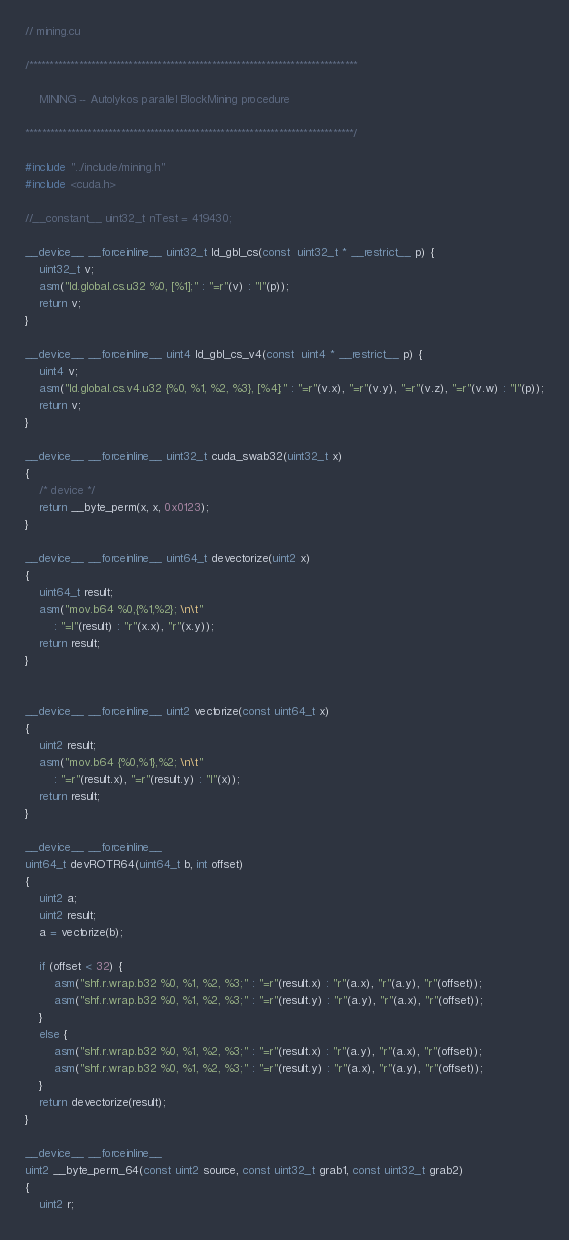<code> <loc_0><loc_0><loc_500><loc_500><_Cuda_>// mining.cu

/*******************************************************************************

    MINING -- Autolykos parallel BlockMining procedure

*******************************************************************************/

#include "../include/mining.h"
#include <cuda.h>

//__constant__ uint32_t nTest = 419430;

__device__ __forceinline__ uint32_t ld_gbl_cs(const  uint32_t * __restrict__ p) {
	uint32_t v;
	asm("ld.global.cs.u32 %0, [%1];" : "=r"(v) : "l"(p));
	return v;
}

__device__ __forceinline__ uint4 ld_gbl_cs_v4(const  uint4 * __restrict__ p) {
	uint4 v;
	asm("ld.global.cs.v4.u32 {%0, %1, %2, %3}, [%4];" : "=r"(v.x), "=r"(v.y), "=r"(v.z), "=r"(v.w) : "l"(p));
	return v;
}

__device__ __forceinline__ uint32_t cuda_swab32(uint32_t x)
{
	/* device */
	return __byte_perm(x, x, 0x0123);
}

__device__ __forceinline__ uint64_t devectorize(uint2 x)
{
	uint64_t result;
	asm("mov.b64 %0,{%1,%2}; \n\t"
		: "=l"(result) : "r"(x.x), "r"(x.y));
	return result;
}


__device__ __forceinline__ uint2 vectorize(const uint64_t x)
{
	uint2 result;
	asm("mov.b64 {%0,%1},%2; \n\t"
		: "=r"(result.x), "=r"(result.y) : "l"(x));
	return result;
}

__device__ __forceinline__
uint64_t devROTR64(uint64_t b, int offset)
{
	uint2 a;
	uint2 result;
	a = vectorize(b);

	if (offset < 32) {
		asm("shf.r.wrap.b32 %0, %1, %2, %3;" : "=r"(result.x) : "r"(a.x), "r"(a.y), "r"(offset));
		asm("shf.r.wrap.b32 %0, %1, %2, %3;" : "=r"(result.y) : "r"(a.y), "r"(a.x), "r"(offset));
	}
	else {
		asm("shf.r.wrap.b32 %0, %1, %2, %3;" : "=r"(result.x) : "r"(a.y), "r"(a.x), "r"(offset));
		asm("shf.r.wrap.b32 %0, %1, %2, %3;" : "=r"(result.y) : "r"(a.x), "r"(a.y), "r"(offset));
	}
	return devectorize(result);
}

__device__ __forceinline__
uint2 __byte_perm_64(const uint2 source, const uint32_t grab1, const uint32_t grab2)
{
	uint2 r;</code> 